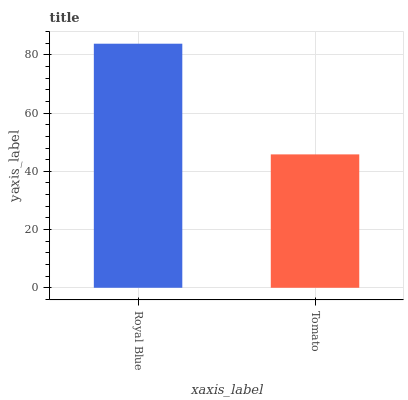Is Tomato the maximum?
Answer yes or no. No. Is Royal Blue greater than Tomato?
Answer yes or no. Yes. Is Tomato less than Royal Blue?
Answer yes or no. Yes. Is Tomato greater than Royal Blue?
Answer yes or no. No. Is Royal Blue less than Tomato?
Answer yes or no. No. Is Royal Blue the high median?
Answer yes or no. Yes. Is Tomato the low median?
Answer yes or no. Yes. Is Tomato the high median?
Answer yes or no. No. Is Royal Blue the low median?
Answer yes or no. No. 